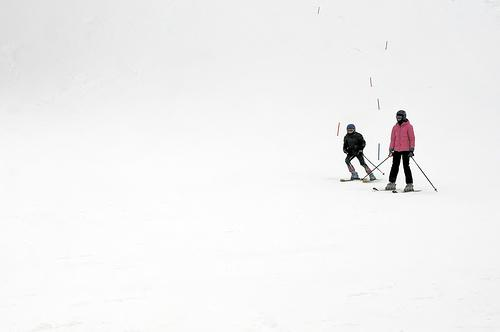Why are sticks stuck into the snow?

Choices:
A) tradition
B) visibility
C) guidance
D) style guidance 